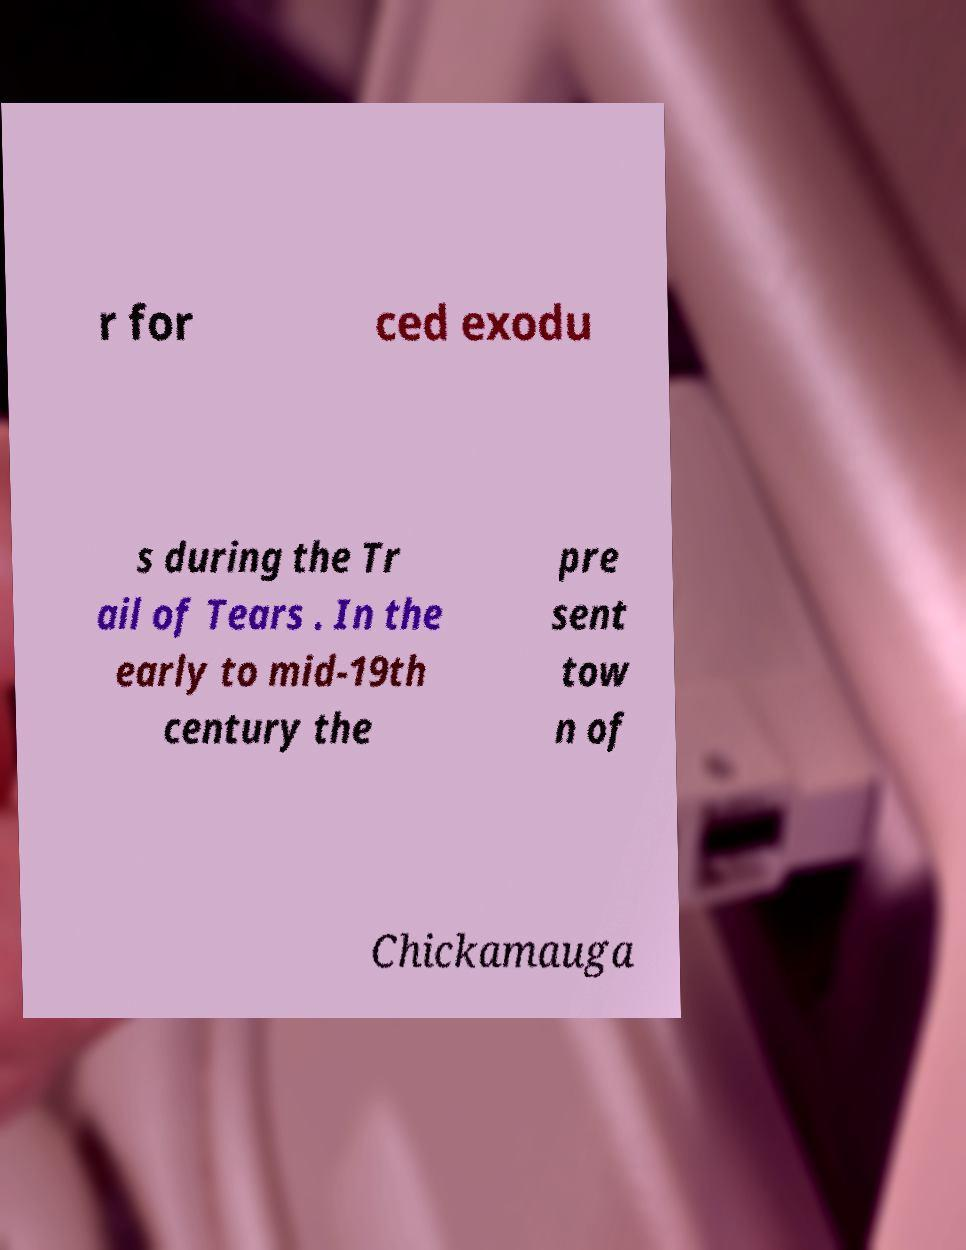Please read and relay the text visible in this image. What does it say? r for ced exodu s during the Tr ail of Tears . In the early to mid-19th century the pre sent tow n of Chickamauga 